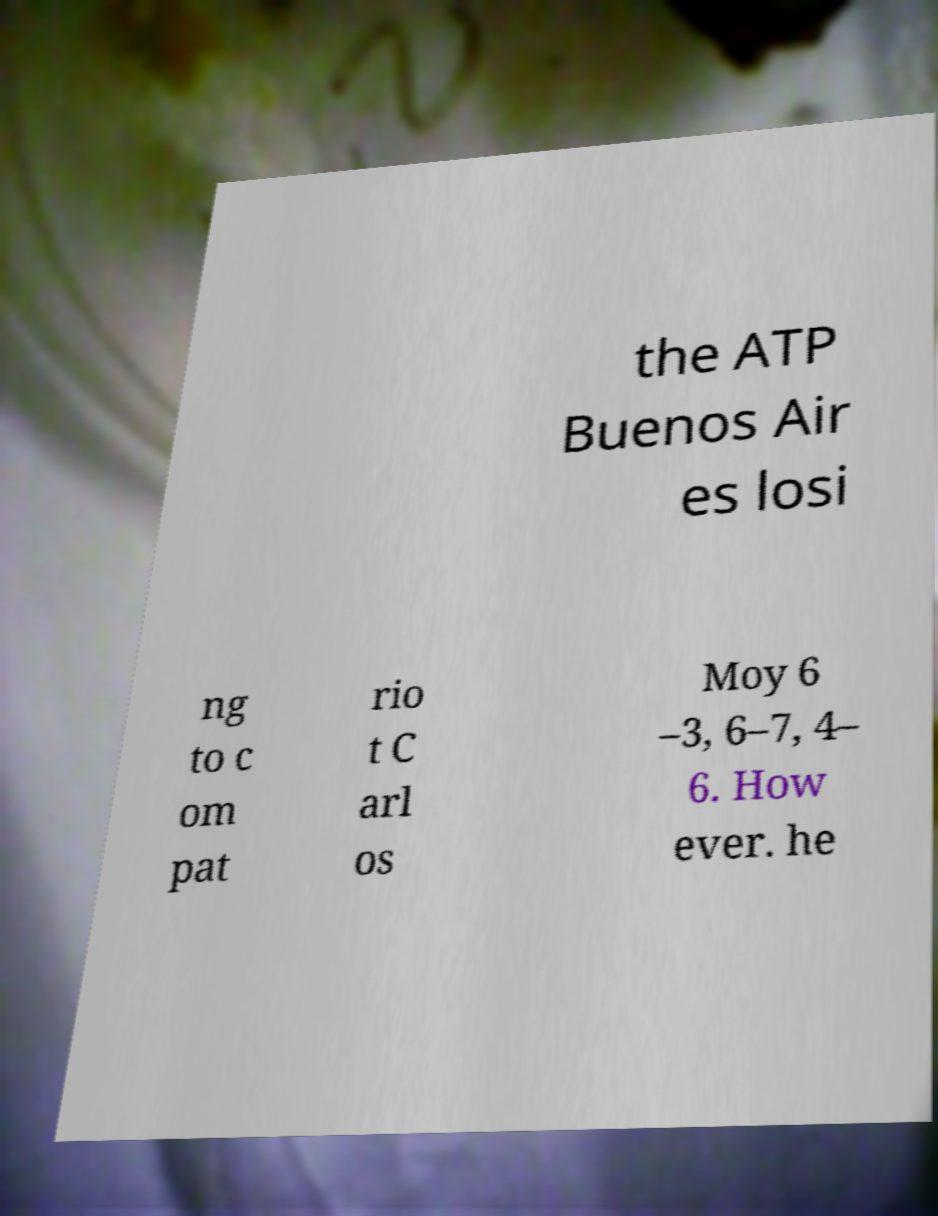For documentation purposes, I need the text within this image transcribed. Could you provide that? the ATP Buenos Air es losi ng to c om pat rio t C arl os Moy 6 –3, 6–7, 4– 6. How ever. he 